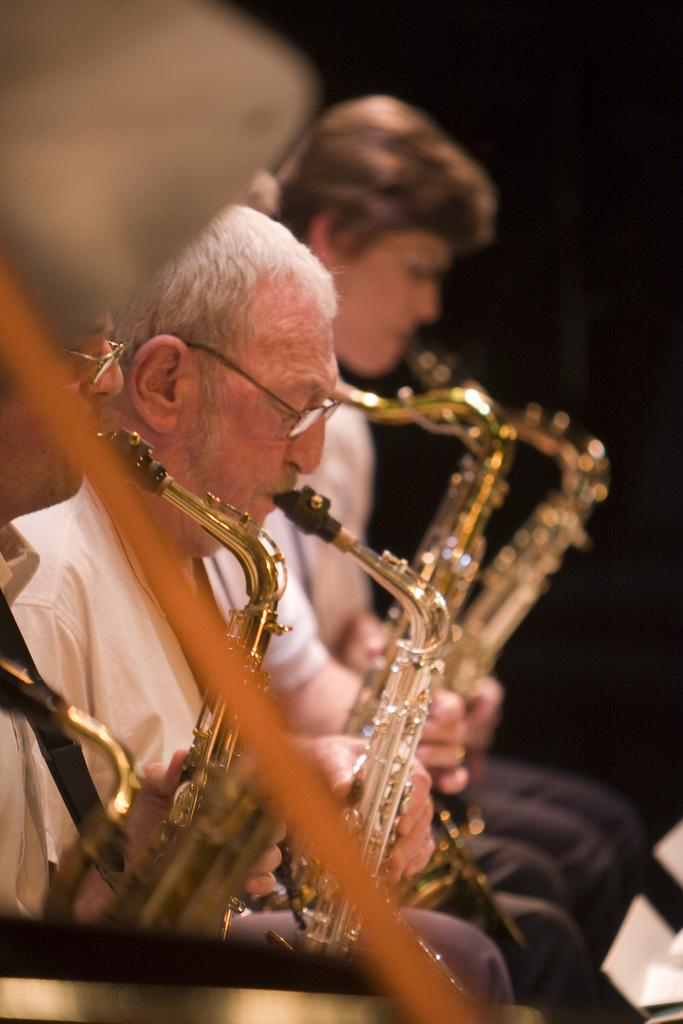How many people are in the image? There are three persons in the image. What are the persons doing in the image? The persons are sitting and playing musical instruments. What are the musical instruments that the persons are holding? The persons are holding musical instruments, but the specific instruments are not mentioned in the facts. What type of bottle can be seen in the seashore scene in the image? There is no bottle or seashore scene present in the image. 